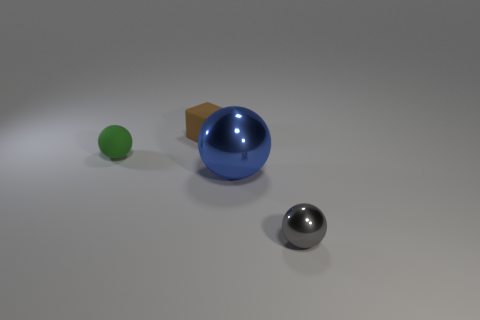What number of other blue things are made of the same material as the blue object?
Ensure brevity in your answer.  0. There is a brown thing; is its size the same as the shiny object that is to the left of the tiny gray object?
Offer a terse response. No. There is a small thing that is both left of the gray thing and in front of the small matte block; what color is it?
Provide a succinct answer. Green. Are there any brown things behind the tiny object behind the green rubber sphere?
Give a very brief answer. No. Are there an equal number of metal objects that are to the left of the tiny brown rubber block and big blue metallic spheres?
Provide a short and direct response. No. There is a tiny sphere to the right of the object that is left of the rubber block; how many green objects are to the left of it?
Provide a short and direct response. 1. Are there any cyan metallic blocks that have the same size as the green matte ball?
Make the answer very short. No. Are there fewer cubes behind the tiny brown object than tiny green objects?
Provide a succinct answer. Yes. The tiny sphere that is in front of the tiny sphere left of the metallic sphere that is left of the small metal ball is made of what material?
Offer a very short reply. Metal. Are there more things that are to the right of the cube than small gray balls on the left side of the large blue sphere?
Offer a terse response. Yes. 